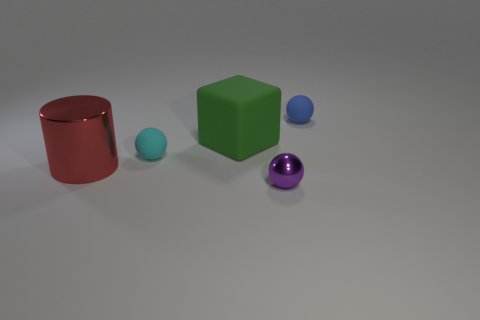Subtract all brown balls. Subtract all purple cylinders. How many balls are left? 3 Add 3 big red things. How many objects exist? 8 Subtract all blocks. How many objects are left? 4 Add 4 big green shiny balls. How many big green shiny balls exist? 4 Subtract 0 red blocks. How many objects are left? 5 Subtract all big things. Subtract all purple metallic balls. How many objects are left? 2 Add 1 metallic things. How many metallic things are left? 3 